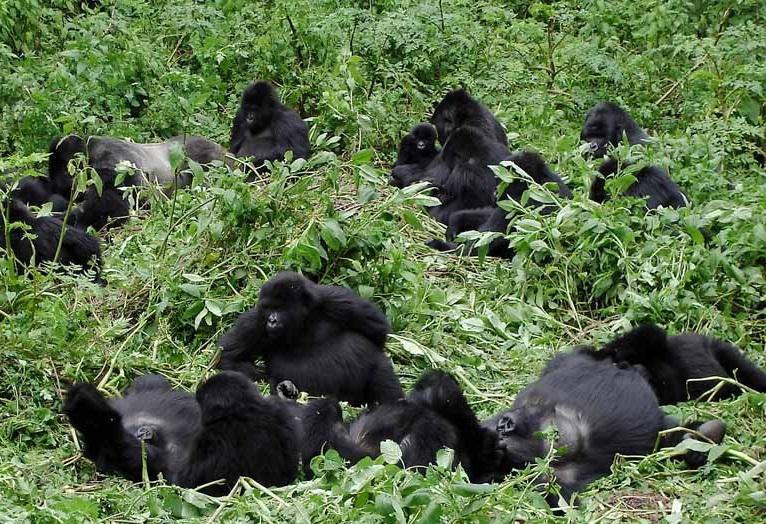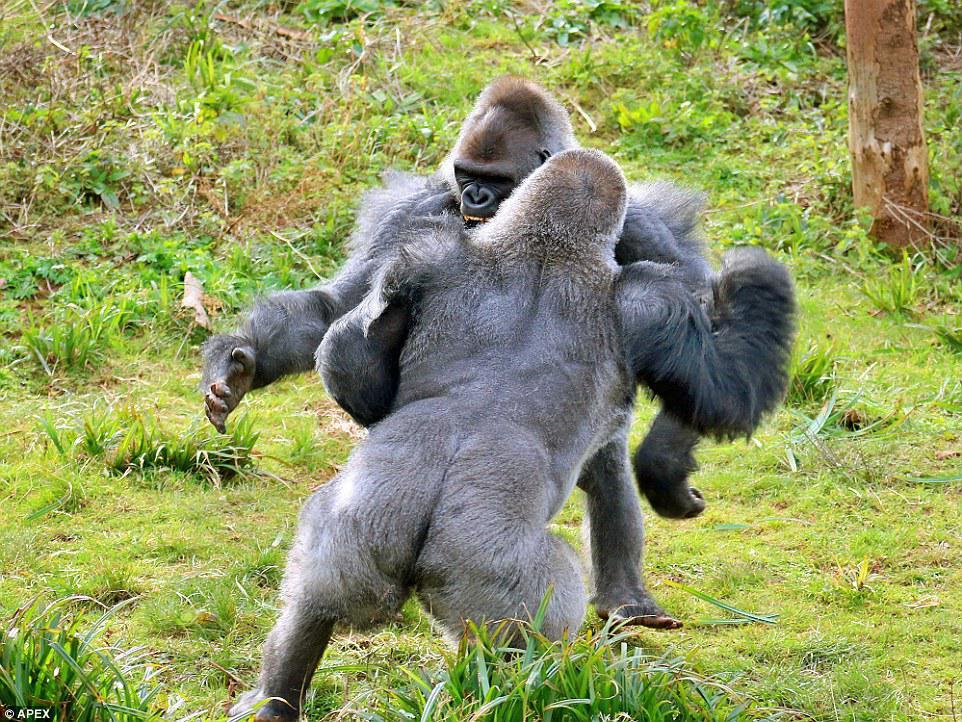The first image is the image on the left, the second image is the image on the right. Examine the images to the left and right. Is the description "An image with no more than three gorillas shows an adult sitting behind a small juvenile ape." accurate? Answer yes or no. No. The first image is the image on the left, the second image is the image on the right. Assess this claim about the two images: "There are exactly two animals in the image on the right.". Correct or not? Answer yes or no. Yes. 